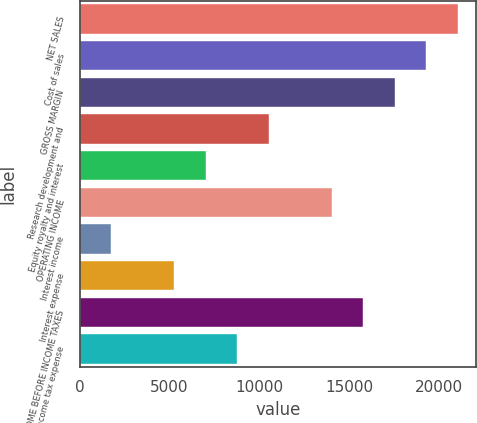<chart> <loc_0><loc_0><loc_500><loc_500><bar_chart><fcel>NET SALES<fcel>Cost of sales<fcel>GROSS MARGIN<fcel>Research development and<fcel>Equity royalty and interest<fcel>OPERATING INCOME<fcel>Interest income<fcel>Interest expense<fcel>INCOME BEFORE INCOME TAXES<fcel>Income tax expense<nl><fcel>21009.2<fcel>19259.1<fcel>17509<fcel>10508.7<fcel>7008.55<fcel>14008.9<fcel>1758.31<fcel>5258.47<fcel>15759<fcel>8758.63<nl></chart> 